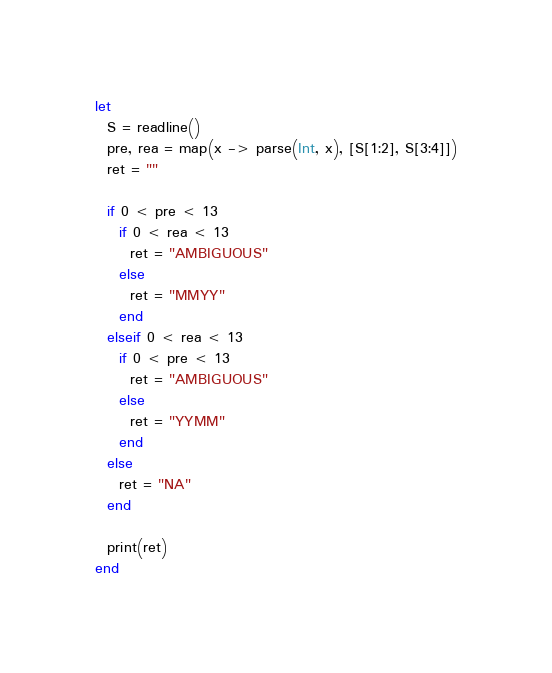Convert code to text. <code><loc_0><loc_0><loc_500><loc_500><_Julia_>let
  S = readline()
  pre, rea = map(x -> parse(Int, x), [S[1:2], S[3:4]])
  ret = ""

  if 0 < pre < 13
    if 0 < rea < 13
      ret = "AMBIGUOUS"
    else
      ret = "MMYY"
    end
  elseif 0 < rea < 13
    if 0 < pre < 13
      ret = "AMBIGUOUS"
    else
      ret = "YYMM"
    end
  else
    ret = "NA"
  end

  print(ret)
end 
</code> 